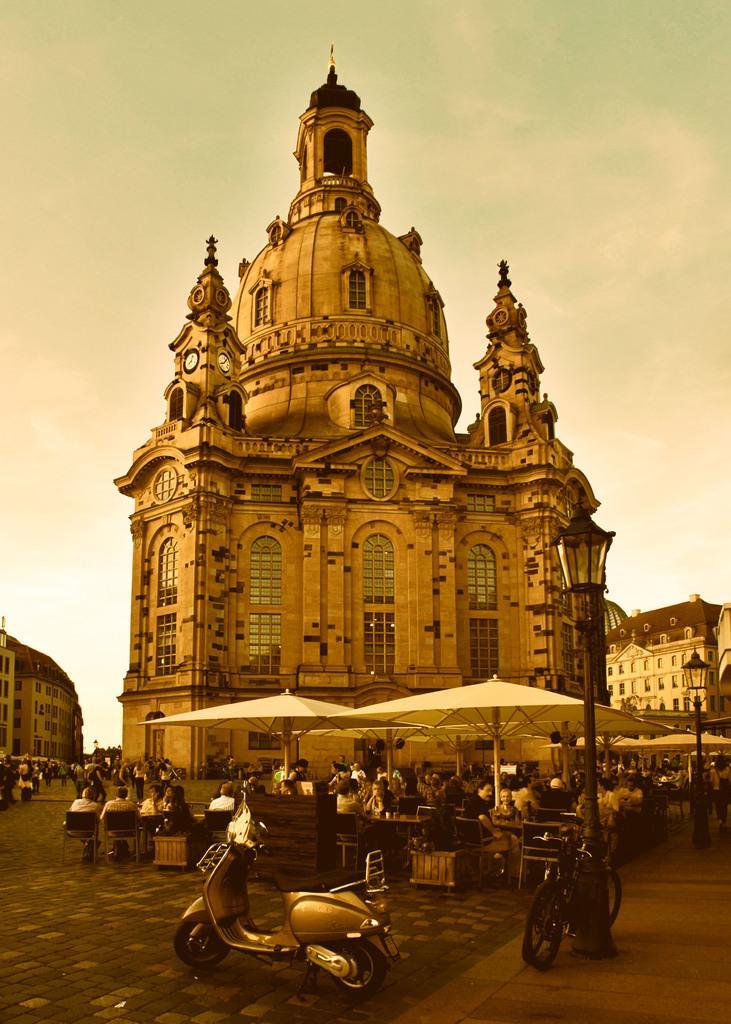How would you summarize this image in a sentence or two? In this image we can see motorcycle and bicycle parked on the ground, a group of people sitting on chairs, some containers placed on the ground. To the right side of the image we can see light poles. In the background, we can see a group of buildings with windows, clocks on towers and the sky. 